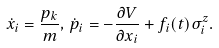Convert formula to latex. <formula><loc_0><loc_0><loc_500><loc_500>\dot { x } _ { i } = \frac { p _ { k } } { m } , \, \dot { p } _ { i } = - \frac { \partial V } { \partial x _ { i } } + f _ { i } ( t ) \sigma ^ { z } _ { i } .</formula> 